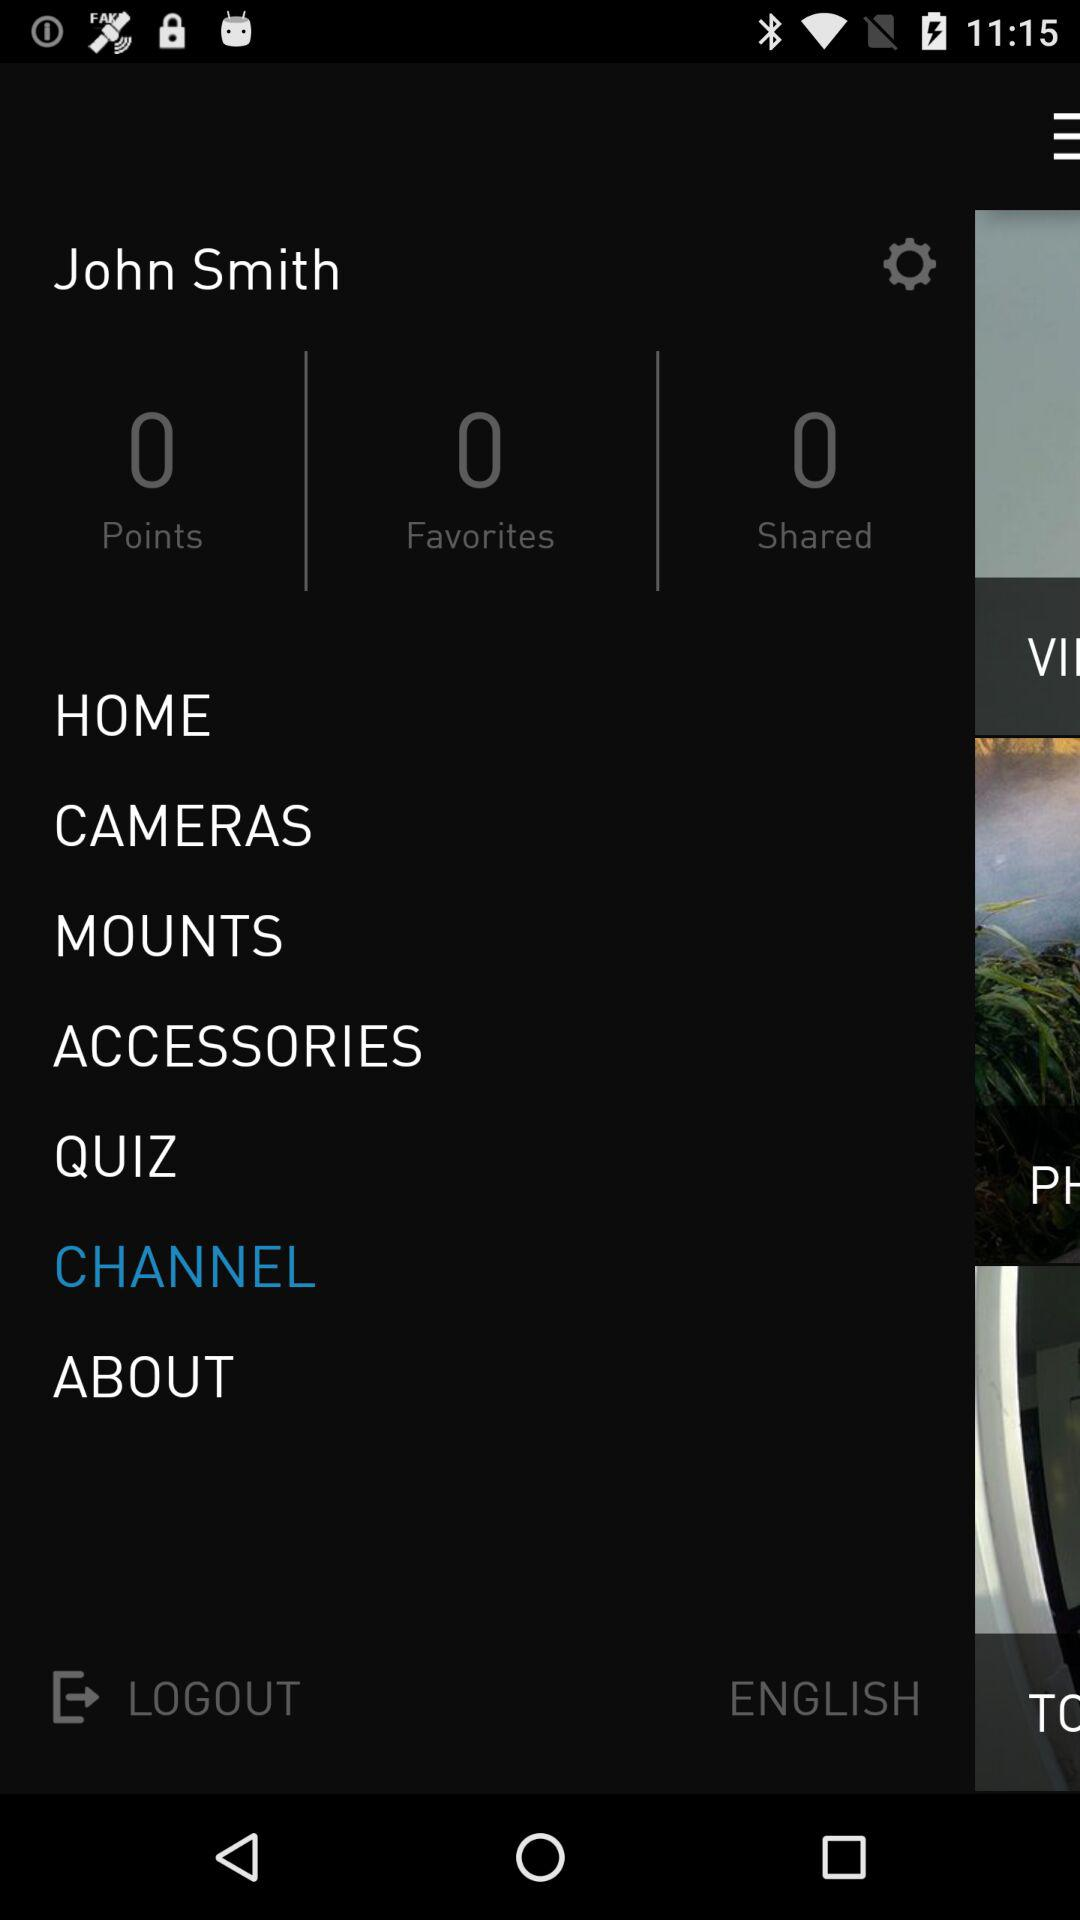How many favorites are there? There are zero favorites. 